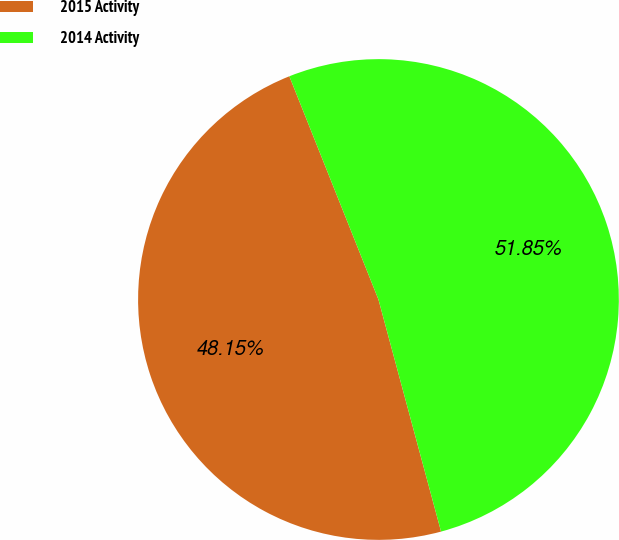Convert chart to OTSL. <chart><loc_0><loc_0><loc_500><loc_500><pie_chart><fcel>2015 Activity<fcel>2014 Activity<nl><fcel>48.15%<fcel>51.85%<nl></chart> 